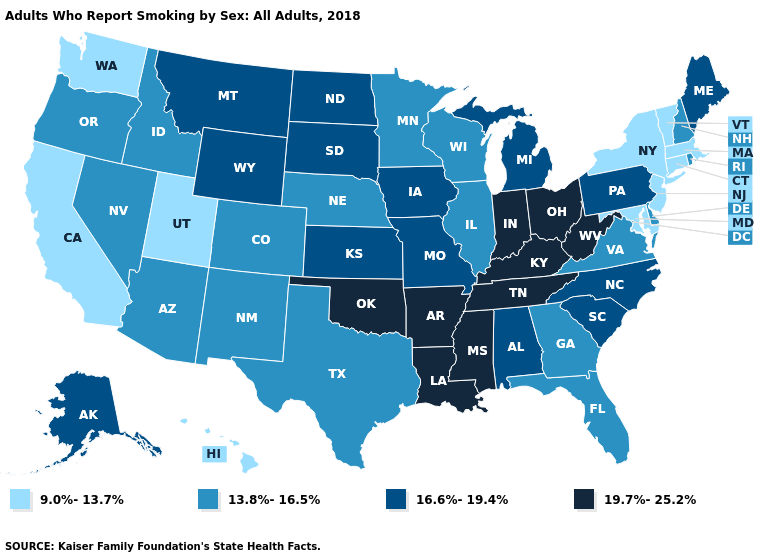Which states have the lowest value in the West?
Keep it brief. California, Hawaii, Utah, Washington. Among the states that border Delaware , which have the lowest value?
Quick response, please. Maryland, New Jersey. Does Iowa have the same value as Ohio?
Answer briefly. No. Among the states that border Missouri , which have the highest value?
Short answer required. Arkansas, Kentucky, Oklahoma, Tennessee. What is the value of Oklahoma?
Write a very short answer. 19.7%-25.2%. What is the highest value in the Northeast ?
Give a very brief answer. 16.6%-19.4%. How many symbols are there in the legend?
Keep it brief. 4. What is the highest value in states that border Maine?
Give a very brief answer. 13.8%-16.5%. Among the states that border Nebraska , does Kansas have the lowest value?
Concise answer only. No. What is the value of Rhode Island?
Short answer required. 13.8%-16.5%. What is the highest value in states that border Ohio?
Keep it brief. 19.7%-25.2%. What is the lowest value in the South?
Quick response, please. 9.0%-13.7%. Name the states that have a value in the range 16.6%-19.4%?
Answer briefly. Alabama, Alaska, Iowa, Kansas, Maine, Michigan, Missouri, Montana, North Carolina, North Dakota, Pennsylvania, South Carolina, South Dakota, Wyoming. Name the states that have a value in the range 13.8%-16.5%?
Short answer required. Arizona, Colorado, Delaware, Florida, Georgia, Idaho, Illinois, Minnesota, Nebraska, Nevada, New Hampshire, New Mexico, Oregon, Rhode Island, Texas, Virginia, Wisconsin. What is the value of Montana?
Write a very short answer. 16.6%-19.4%. 